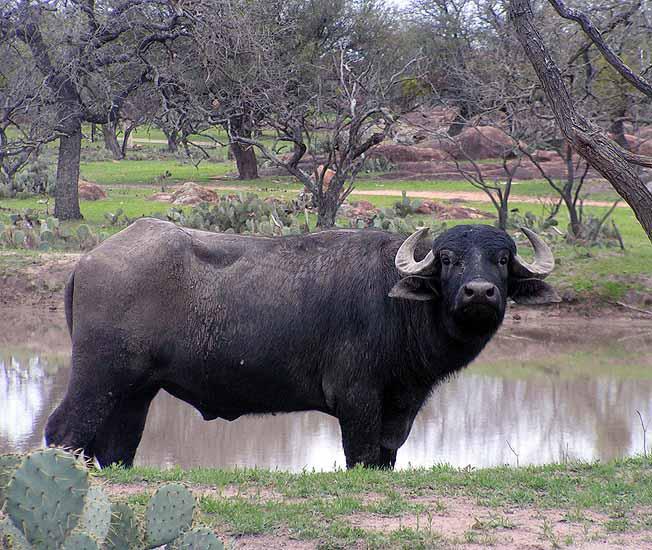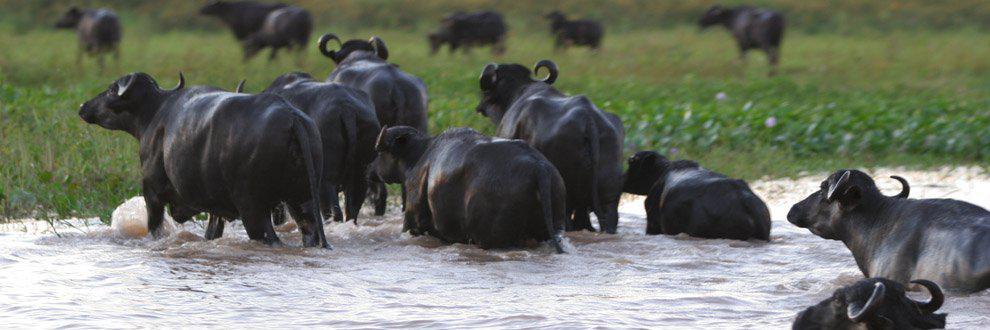The first image is the image on the left, the second image is the image on the right. Examine the images to the left and right. Is the description "The left image features one camera-gazing water buffalo that is standing directly in front of a wet area." accurate? Answer yes or no. Yes. 